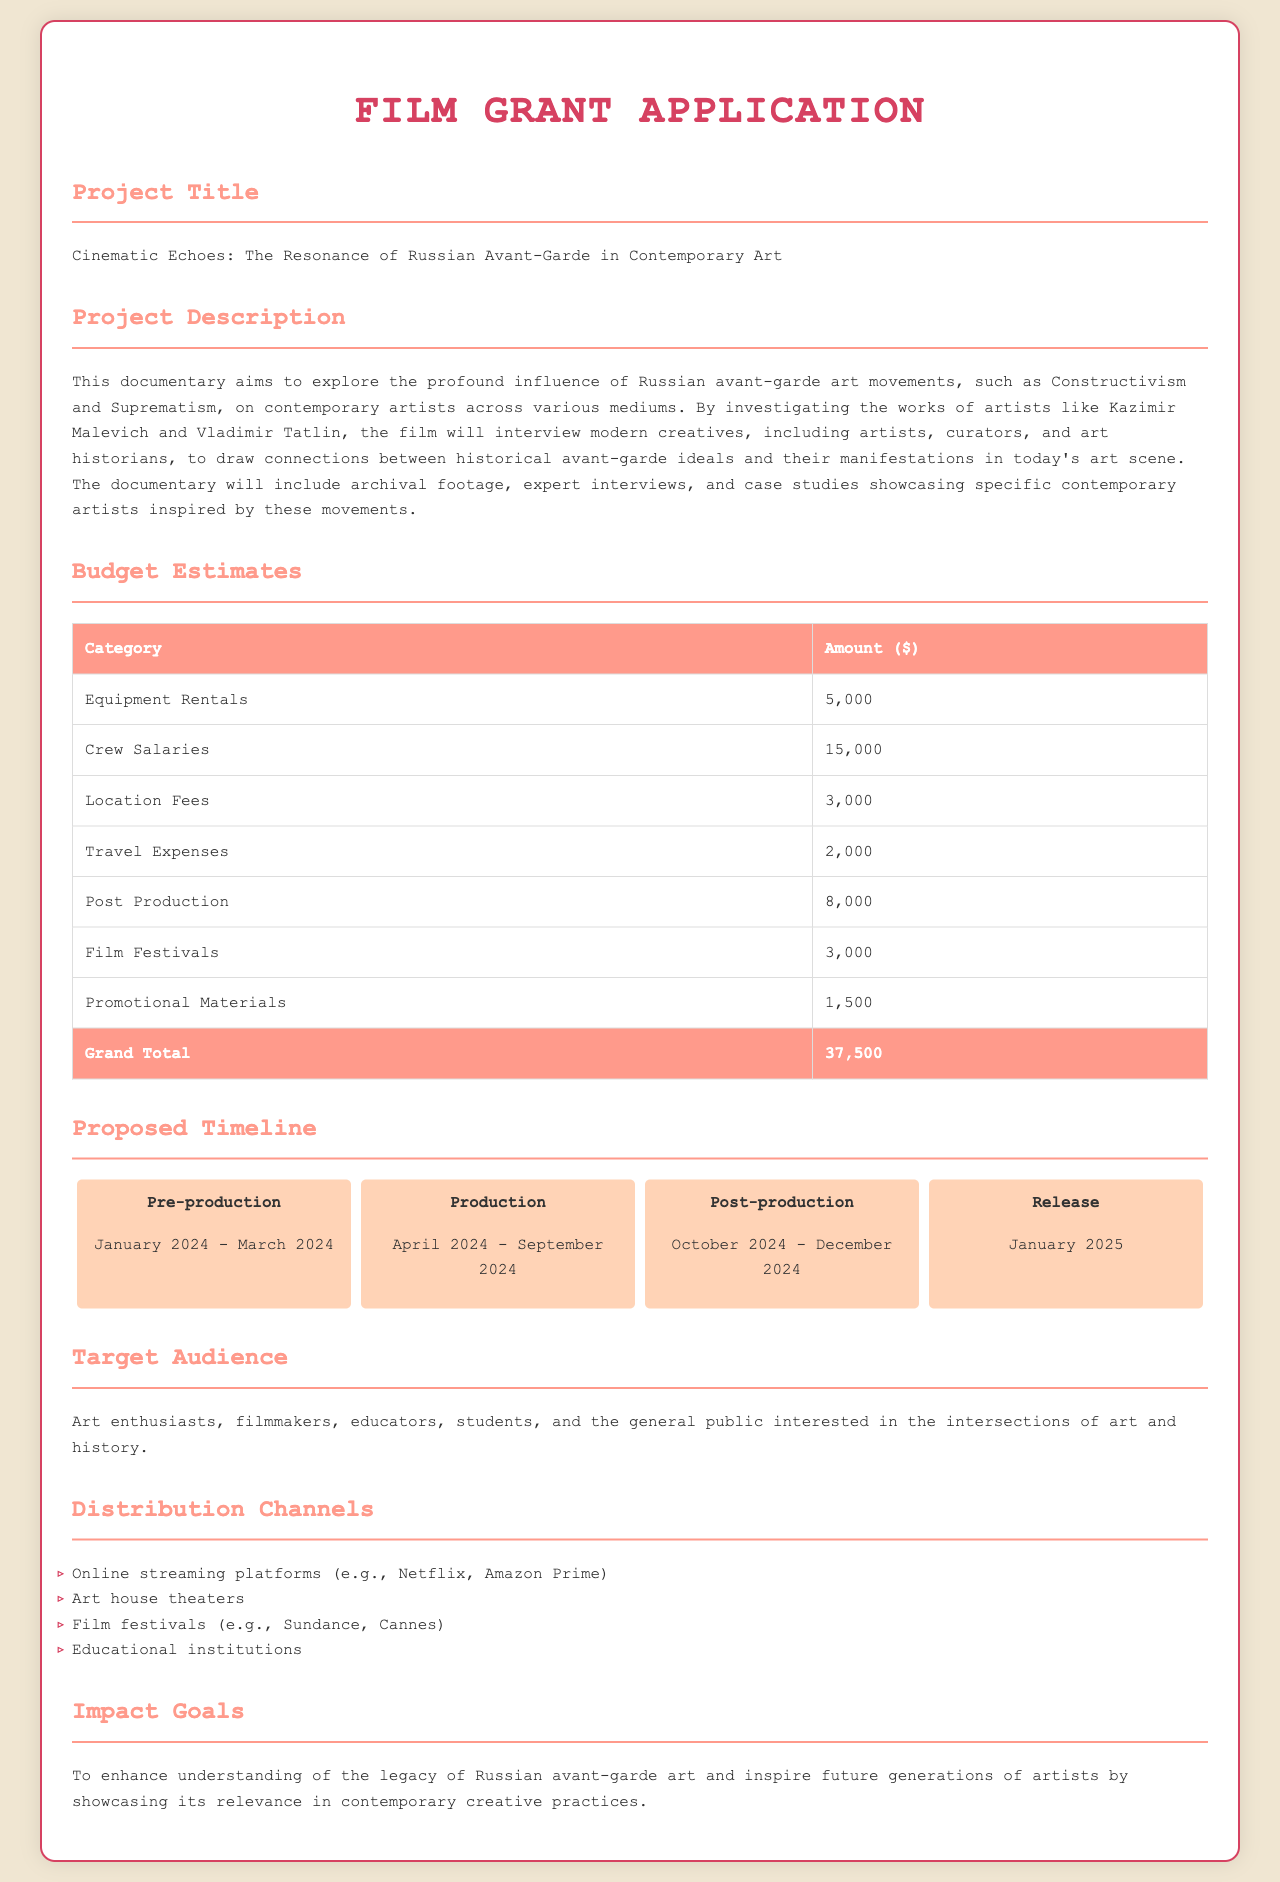What is the project title? The project title is stated in the document, which is "Cinematic Echoes: The Resonance of Russian Avant-Garde in Contemporary Art."
Answer: Cinematic Echoes: The Resonance of Russian Avant-Garde in Contemporary Art What is the total budget estimate? The total budget estimate is listed at the bottom of the budget table in the document.
Answer: 37,500 During which months will the production phase occur? The production phase is detailed in the proposed timeline section, which specifies the months for production.
Answer: April 2024 - September 2024 What is the main target audience for the documentary? The target audience is specifically mentioned in the document under the target audience section.
Answer: Art enthusiasts, filmmakers, educators, students, and the general public What kind of distribution channels are mentioned? The distribution channels are listed in bullet points under the distribution channels section in the document.
Answer: Online streaming platforms, Art house theaters, Film festivals, Educational institutions What is the focus of the documentary? The focus of the documentary is summarized in the project description, outlining the main theme it addresses.
Answer: The profound influence of Russian avant-garde art movements on contemporary artists What is the primary goal of the documentary's impact? The impact goal is articulated clearly in the document and conveys what the filmmakers aim to achieve.
Answer: Enhance understanding of the legacy of Russian avant-garde art In which month is the release planned? The release month is mentioned in the proposed timeline, indicating when the documentary is scheduled to be released.
Answer: January 2025 What will be included in the documentary besides interviews? The project description notes additional elements beyond interviews that will be incorporated into the film.
Answer: Archival footage, expert interviews, and case studies 